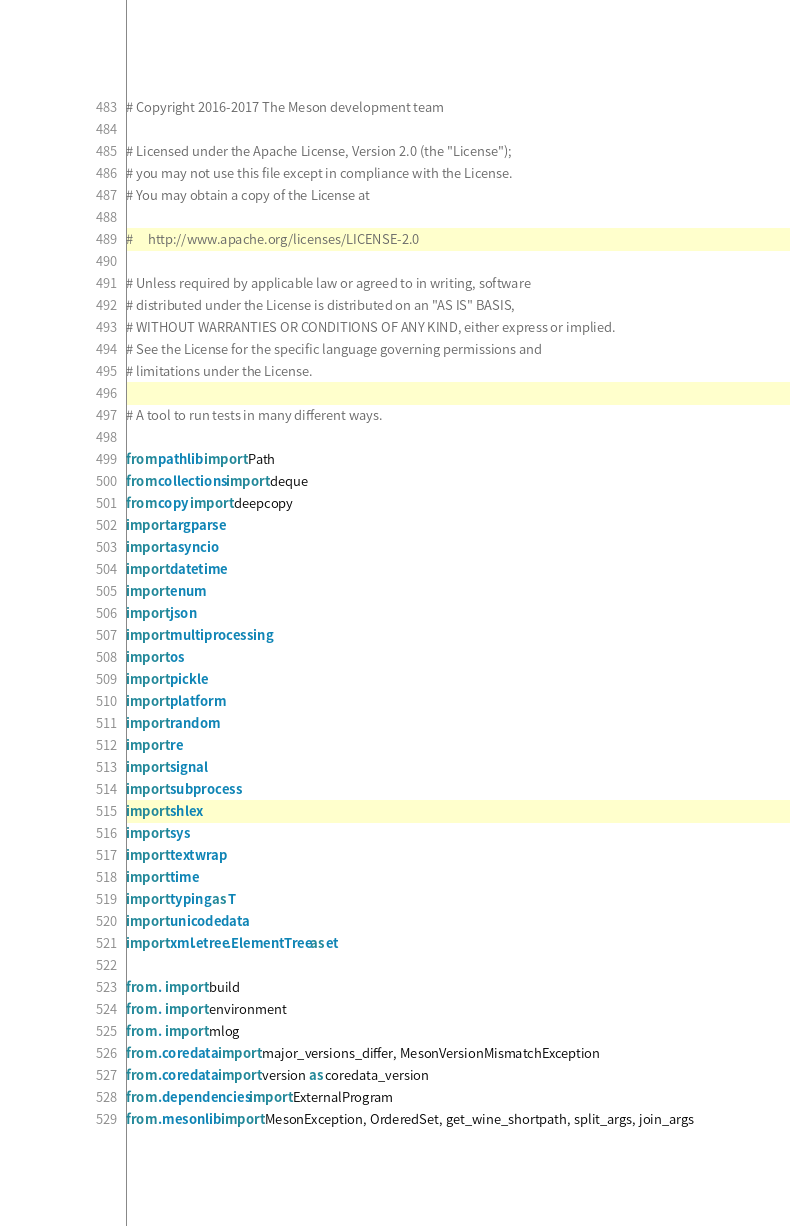Convert code to text. <code><loc_0><loc_0><loc_500><loc_500><_Python_># Copyright 2016-2017 The Meson development team

# Licensed under the Apache License, Version 2.0 (the "License");
# you may not use this file except in compliance with the License.
# You may obtain a copy of the License at

#     http://www.apache.org/licenses/LICENSE-2.0

# Unless required by applicable law or agreed to in writing, software
# distributed under the License is distributed on an "AS IS" BASIS,
# WITHOUT WARRANTIES OR CONDITIONS OF ANY KIND, either express or implied.
# See the License for the specific language governing permissions and
# limitations under the License.

# A tool to run tests in many different ways.

from pathlib import Path
from collections import deque
from copy import deepcopy
import argparse
import asyncio
import datetime
import enum
import json
import multiprocessing
import os
import pickle
import platform
import random
import re
import signal
import subprocess
import shlex
import sys
import textwrap
import time
import typing as T
import unicodedata
import xml.etree.ElementTree as et

from . import build
from . import environment
from . import mlog
from .coredata import major_versions_differ, MesonVersionMismatchException
from .coredata import version as coredata_version
from .dependencies import ExternalProgram
from .mesonlib import MesonException, OrderedSet, get_wine_shortpath, split_args, join_args</code> 